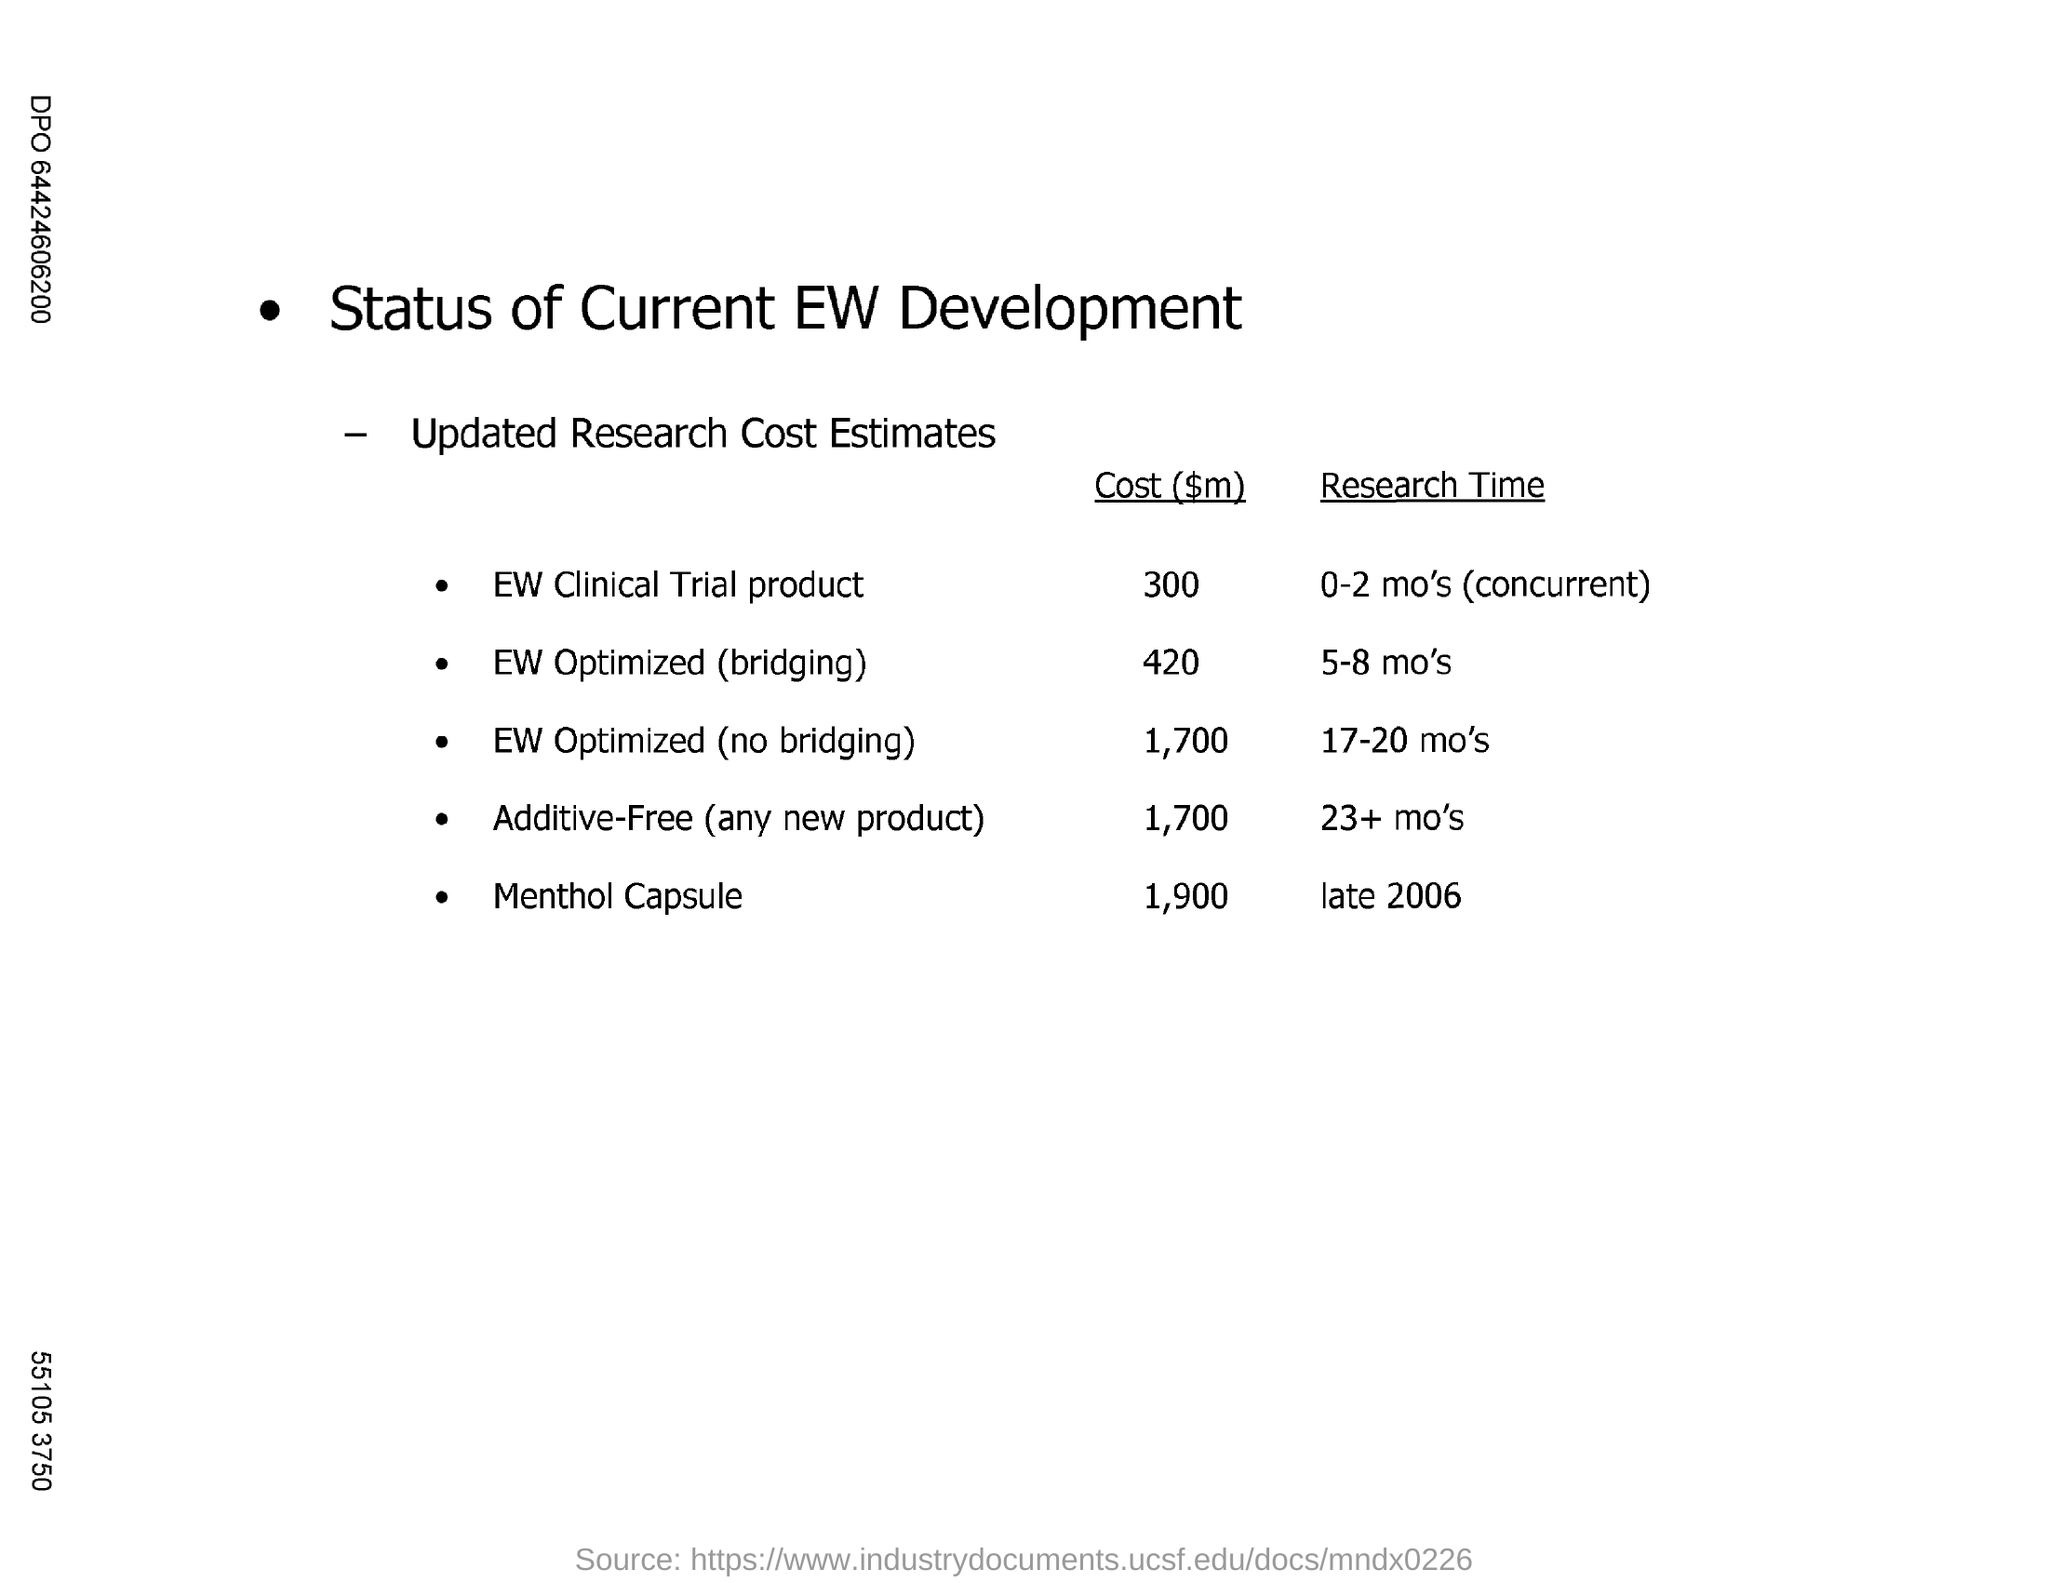What is the "Cost" for "Menthol Capsule"?
Offer a terse response. 1,900. What is the "Research Time" for "Menthol Capsule"?
Offer a terse response. Late 2006. What is the "Cost" for "EW Clinical Trial Product"?
Offer a very short reply. 300. What is the Research Time for EW Clinical Trial Product?
Your answer should be very brief. 0-2 mo's (concurrent). 